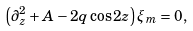Convert formula to latex. <formula><loc_0><loc_0><loc_500><loc_500>\left ( \partial _ { z } ^ { 2 } + A - 2 q \cos 2 z \right ) \xi _ { m } = 0 ,</formula> 